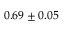<formula> <loc_0><loc_0><loc_500><loc_500>0 . 6 9 \pm 0 . 0 5</formula> 